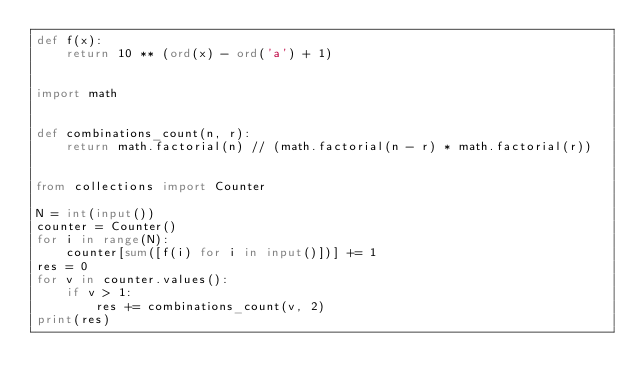Convert code to text. <code><loc_0><loc_0><loc_500><loc_500><_Python_>def f(x):
    return 10 ** (ord(x) - ord('a') + 1)


import math


def combinations_count(n, r):
    return math.factorial(n) // (math.factorial(n - r) * math.factorial(r))


from collections import Counter

N = int(input())
counter = Counter()
for i in range(N):
    counter[sum([f(i) for i in input()])] += 1
res = 0
for v in counter.values():
    if v > 1:
        res += combinations_count(v, 2)
print(res)</code> 